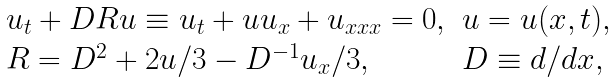<formula> <loc_0><loc_0><loc_500><loc_500>\begin{array} [ b ] { l l } u _ { t } + D R u \equiv u _ { t } + u u _ { x } + u _ { x x x } = 0 , & u = u ( x , t ) , \\ R = D ^ { 2 } + 2 u / 3 - D ^ { - 1 } u _ { x } / 3 , & D \equiv d / d x , \end{array}</formula> 